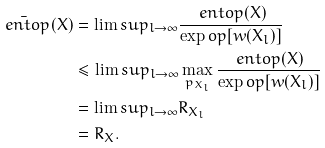Convert formula to latex. <formula><loc_0><loc_0><loc_500><loc_500>\bar { \ e n t o p } ( X ) & = \lim s u p _ { l \rightarrow \infty } \frac { \ e n t o p ( X ) } { \exp o p [ w ( X _ { l } ) ] } \\ & \leq \lim s u p _ { l \rightarrow \infty } \max _ { p _ { X _ { l } } } \frac { \ e n t o p ( X ) } { \exp o p [ w ( X _ { l } ) ] } \\ & = \lim s u p _ { l \rightarrow \infty } R _ { X _ { l } } \\ & = R _ { X } .</formula> 